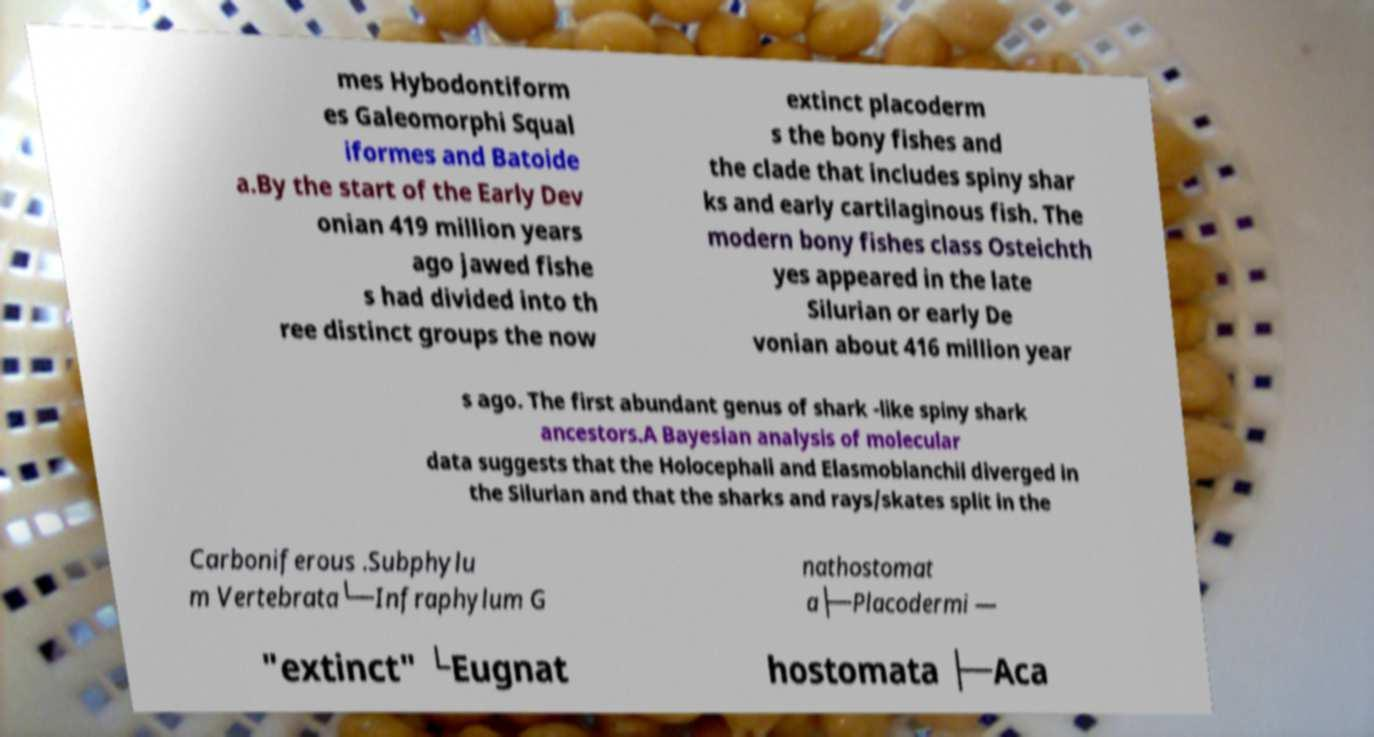Could you extract and type out the text from this image? mes Hybodontiform es Galeomorphi Squal iformes and Batoide a.By the start of the Early Dev onian 419 million years ago jawed fishe s had divided into th ree distinct groups the now extinct placoderm s the bony fishes and the clade that includes spiny shar ks and early cartilaginous fish. The modern bony fishes class Osteichth yes appeared in the late Silurian or early De vonian about 416 million year s ago. The first abundant genus of shark -like spiny shark ancestors.A Bayesian analysis of molecular data suggests that the Holocephali and Elasmoblanchii diverged in the Silurian and that the sharks and rays/skates split in the Carboniferous .Subphylu m Vertebrata└─Infraphylum G nathostomat a├─Placodermi — "extinct" └Eugnat hostomata ├─Aca 